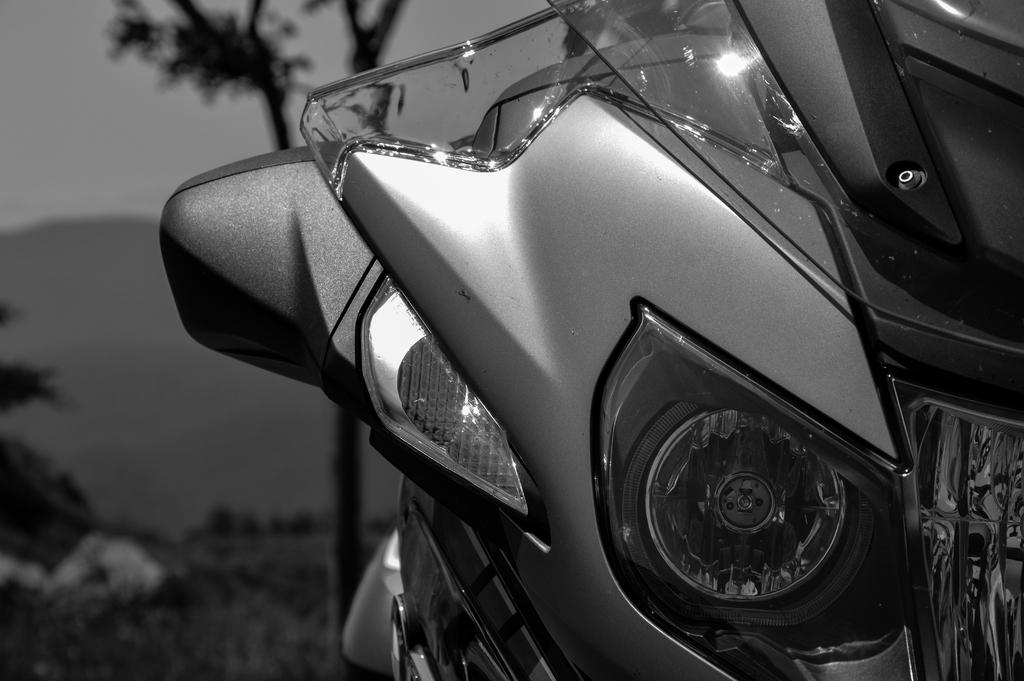What is the color scheme of the image? The image is black and white. What is the main subject in the center of the image? There is a bike in the center of the image. What can be seen in the background of the image? There is a tree, a hill, and the sky visible in the background of the image. Where is the market located in the image? There is no market present in the image. What type of board is being used by the person riding the bike in the image? There is no person riding the bike in the image, and therefore no board can be observed. 